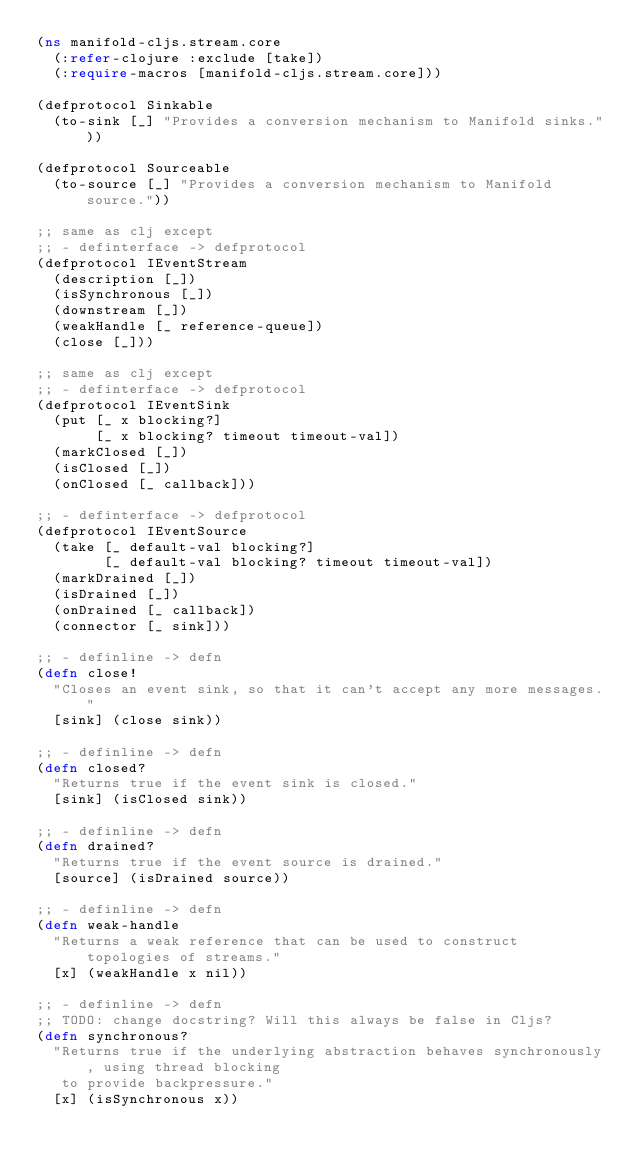Convert code to text. <code><loc_0><loc_0><loc_500><loc_500><_Clojure_>(ns manifold-cljs.stream.core
  (:refer-clojure :exclude [take])
  (:require-macros [manifold-cljs.stream.core]))

(defprotocol Sinkable
  (to-sink [_] "Provides a conversion mechanism to Manifold sinks."))

(defprotocol Sourceable
  (to-source [_] "Provides a conversion mechanism to Manifold source."))

;; same as clj except
;; - definterface -> defprotocol
(defprotocol IEventStream
  (description [_])
  (isSynchronous [_])
  (downstream [_])
  (weakHandle [_ reference-queue])
  (close [_]))

;; same as clj except
;; - definterface -> defprotocol
(defprotocol IEventSink
  (put [_ x blocking?]
       [_ x blocking? timeout timeout-val])
  (markClosed [_])
  (isClosed [_])
  (onClosed [_ callback]))

;; - definterface -> defprotocol
(defprotocol IEventSource
  (take [_ default-val blocking?]
        [_ default-val blocking? timeout timeout-val])
  (markDrained [_])
  (isDrained [_])
  (onDrained [_ callback])
  (connector [_ sink]))

;; - definline -> defn
(defn close!
  "Closes an event sink, so that it can't accept any more messages."
  [sink] (close sink))

;; - definline -> defn
(defn closed?
  "Returns true if the event sink is closed."
  [sink] (isClosed sink))

;; - definline -> defn
(defn drained?
  "Returns true if the event source is drained."
  [source] (isDrained source))

;; - definline -> defn
(defn weak-handle
  "Returns a weak reference that can be used to construct topologies of streams."
  [x] (weakHandle x nil))

;; - definline -> defn
;; TODO: change docstring? Will this always be false in Cljs?
(defn synchronous?
  "Returns true if the underlying abstraction behaves synchronously, using thread blocking
   to provide backpressure."
  [x] (isSynchronous x))
</code> 